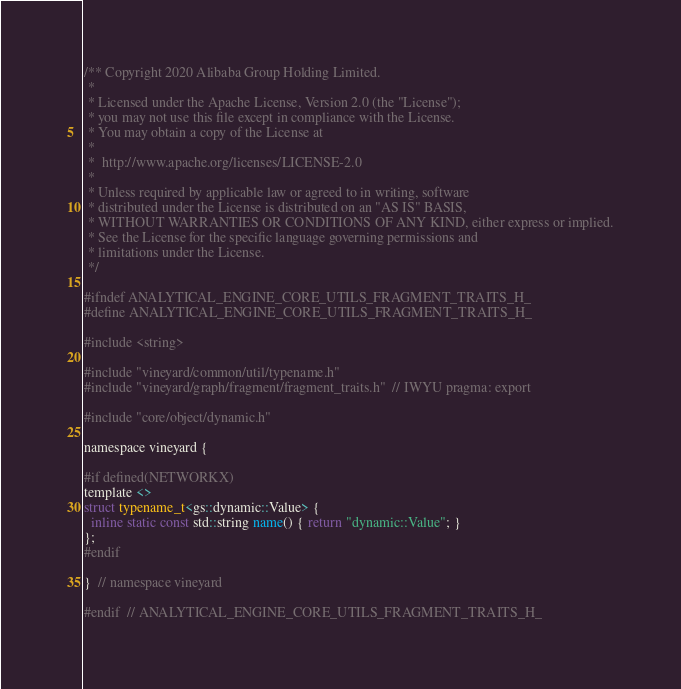<code> <loc_0><loc_0><loc_500><loc_500><_C_>/** Copyright 2020 Alibaba Group Holding Limited.
 *
 * Licensed under the Apache License, Version 2.0 (the "License");
 * you may not use this file except in compliance with the License.
 * You may obtain a copy of the License at
 *
 * 	http://www.apache.org/licenses/LICENSE-2.0
 *
 * Unless required by applicable law or agreed to in writing, software
 * distributed under the License is distributed on an "AS IS" BASIS,
 * WITHOUT WARRANTIES OR CONDITIONS OF ANY KIND, either express or implied.
 * See the License for the specific language governing permissions and
 * limitations under the License.
 */

#ifndef ANALYTICAL_ENGINE_CORE_UTILS_FRAGMENT_TRAITS_H_
#define ANALYTICAL_ENGINE_CORE_UTILS_FRAGMENT_TRAITS_H_

#include <string>

#include "vineyard/common/util/typename.h"
#include "vineyard/graph/fragment/fragment_traits.h"  // IWYU pragma: export

#include "core/object/dynamic.h"

namespace vineyard {

#if defined(NETWORKX)
template <>
struct typename_t<gs::dynamic::Value> {
  inline static const std::string name() { return "dynamic::Value"; }
};
#endif

}  // namespace vineyard

#endif  // ANALYTICAL_ENGINE_CORE_UTILS_FRAGMENT_TRAITS_H_
</code> 